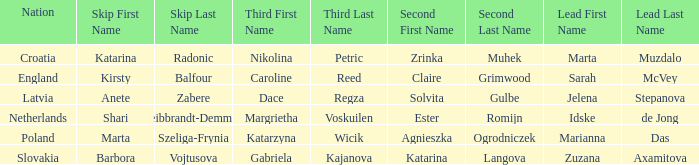Which lead has Kirsty Balfour as second? Sarah McVey. 